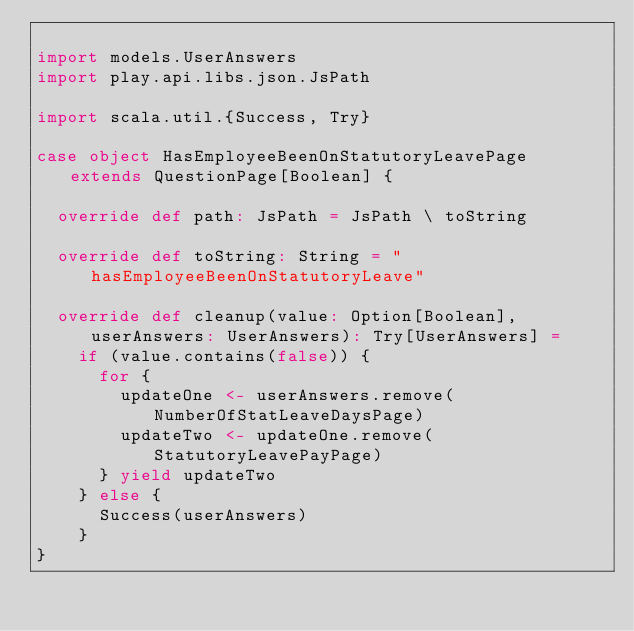Convert code to text. <code><loc_0><loc_0><loc_500><loc_500><_Scala_>
import models.UserAnswers
import play.api.libs.json.JsPath

import scala.util.{Success, Try}

case object HasEmployeeBeenOnStatutoryLeavePage extends QuestionPage[Boolean] {

  override def path: JsPath = JsPath \ toString

  override def toString: String = "hasEmployeeBeenOnStatutoryLeave"

  override def cleanup(value: Option[Boolean], userAnswers: UserAnswers): Try[UserAnswers] =
    if (value.contains(false)) {
      for {
        updateOne <- userAnswers.remove(NumberOfStatLeaveDaysPage)
        updateTwo <- updateOne.remove(StatutoryLeavePayPage)
      } yield updateTwo
    } else {
      Success(userAnswers)
    }
}
</code> 